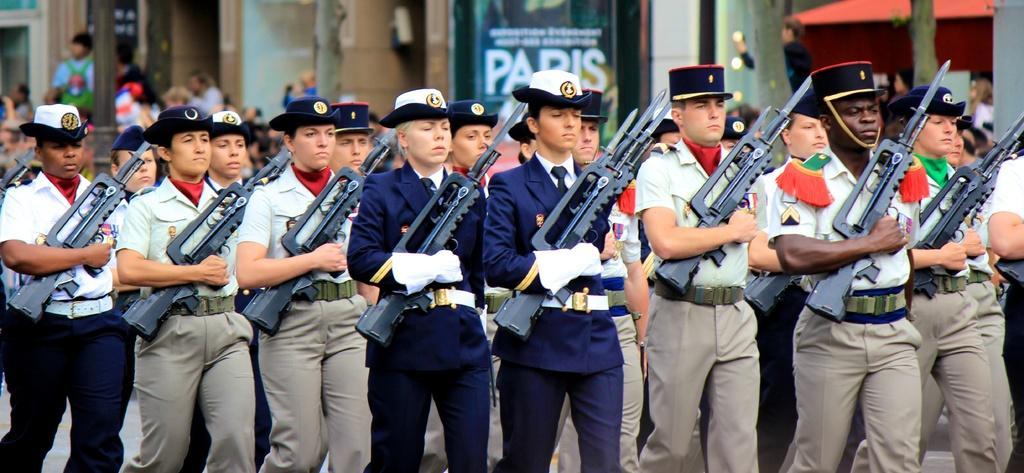Can you describe this image briefly? In this picture we can see a group of people and they are holding guns with their hands and in the background we can see few people and some objects. 